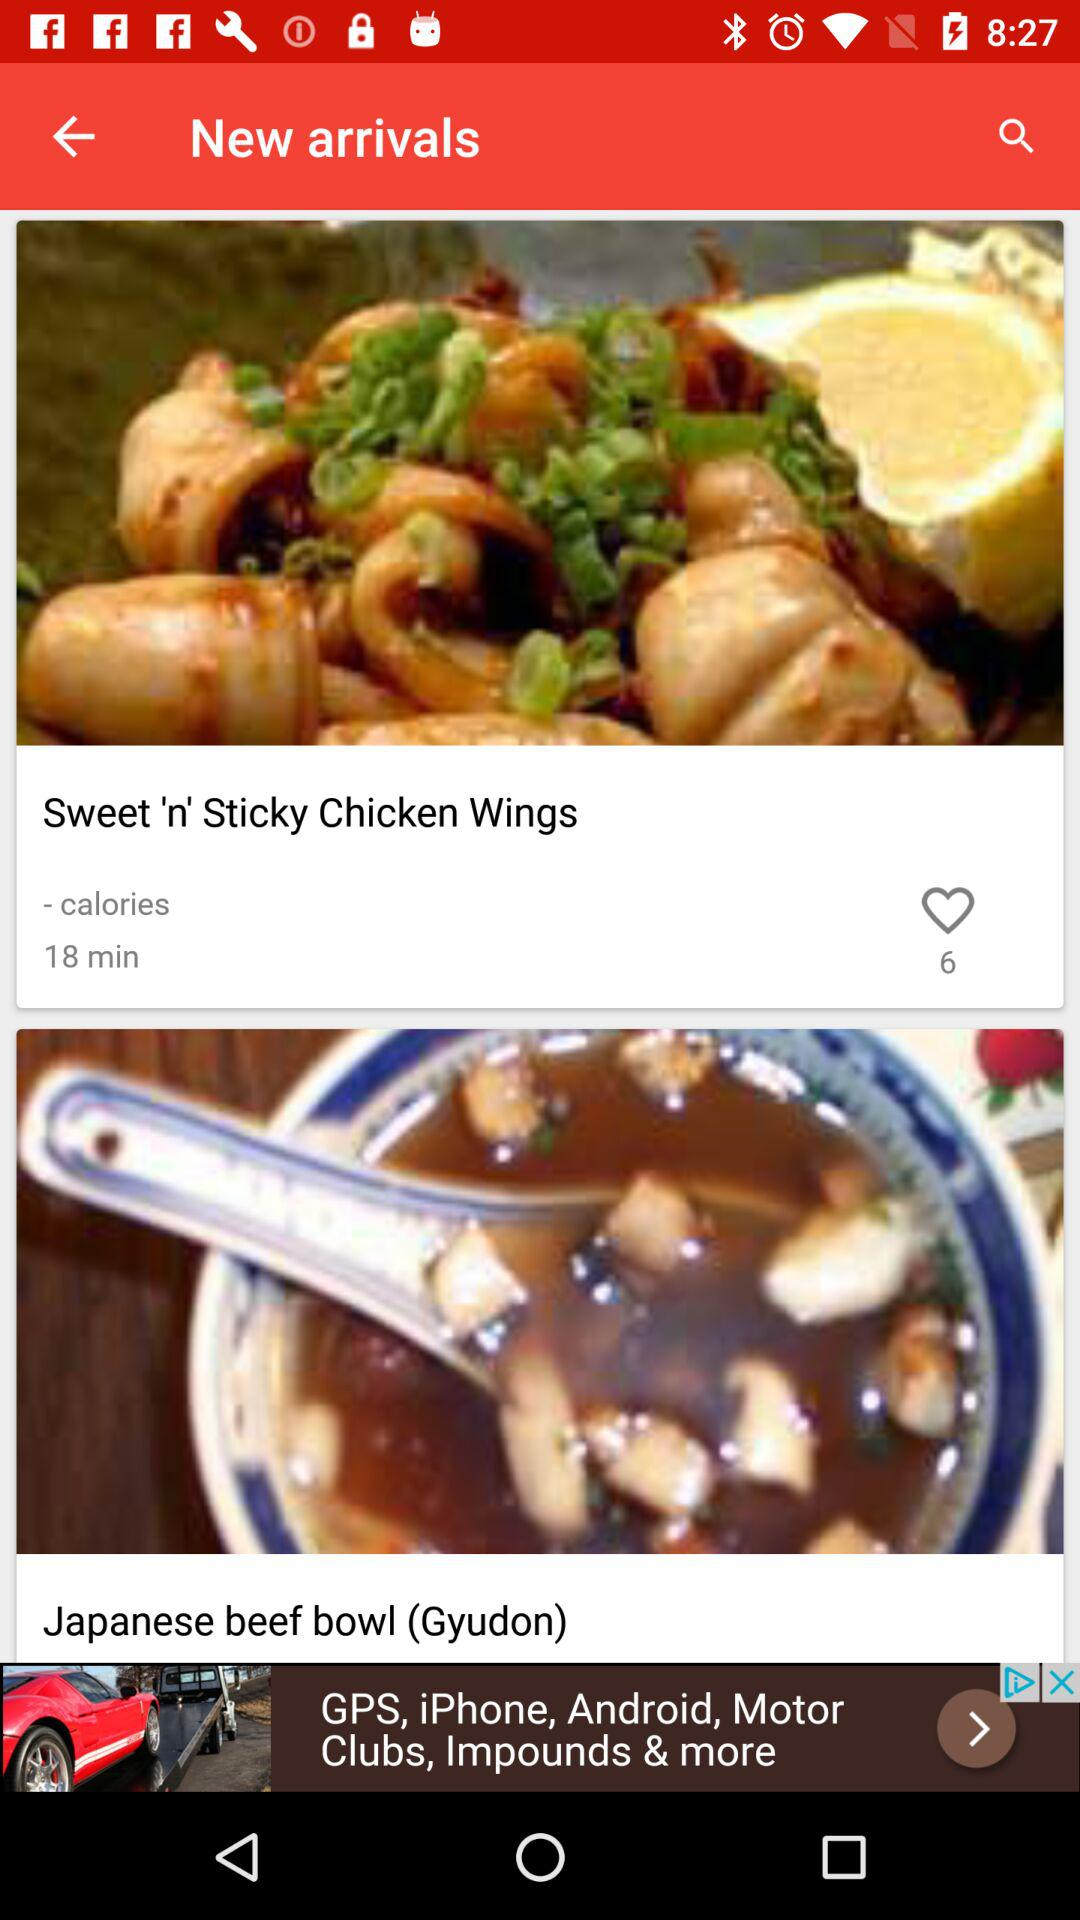How many likes did "Sweet 'n' Sticky Chicken Wings" receive? "Sweet 'n' Sticky Chicken Wings" received 6 likes. 